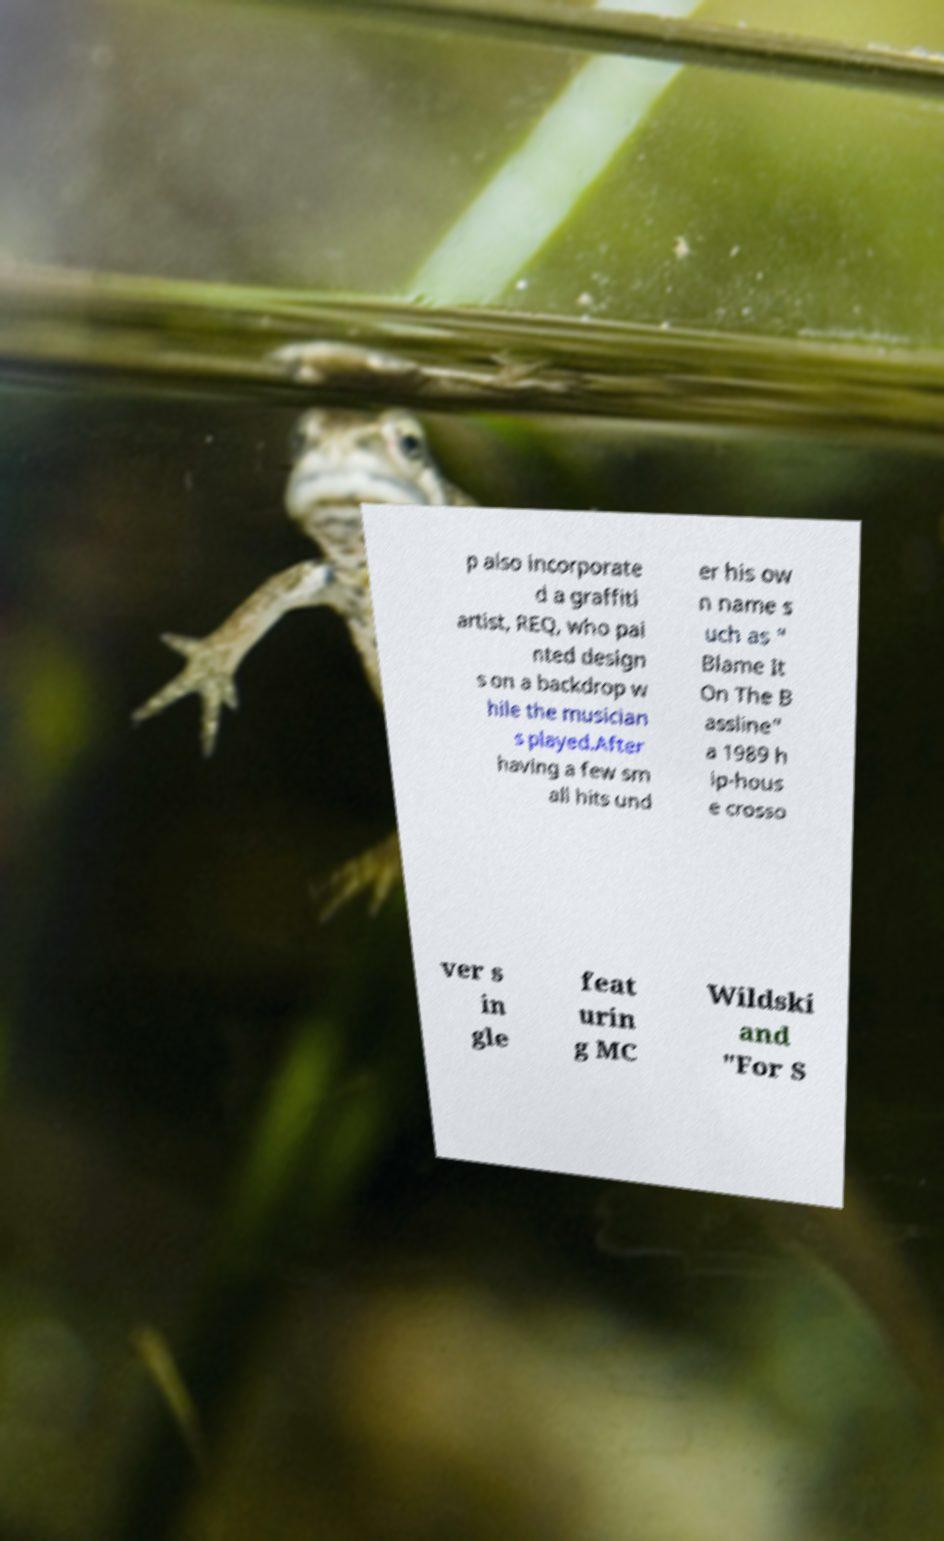There's text embedded in this image that I need extracted. Can you transcribe it verbatim? p also incorporate d a graffiti artist, REQ, who pai nted design s on a backdrop w hile the musician s played.After having a few sm all hits und er his ow n name s uch as " Blame It On The B assline" a 1989 h ip-hous e crosso ver s in gle feat urin g MC Wildski and "For S 